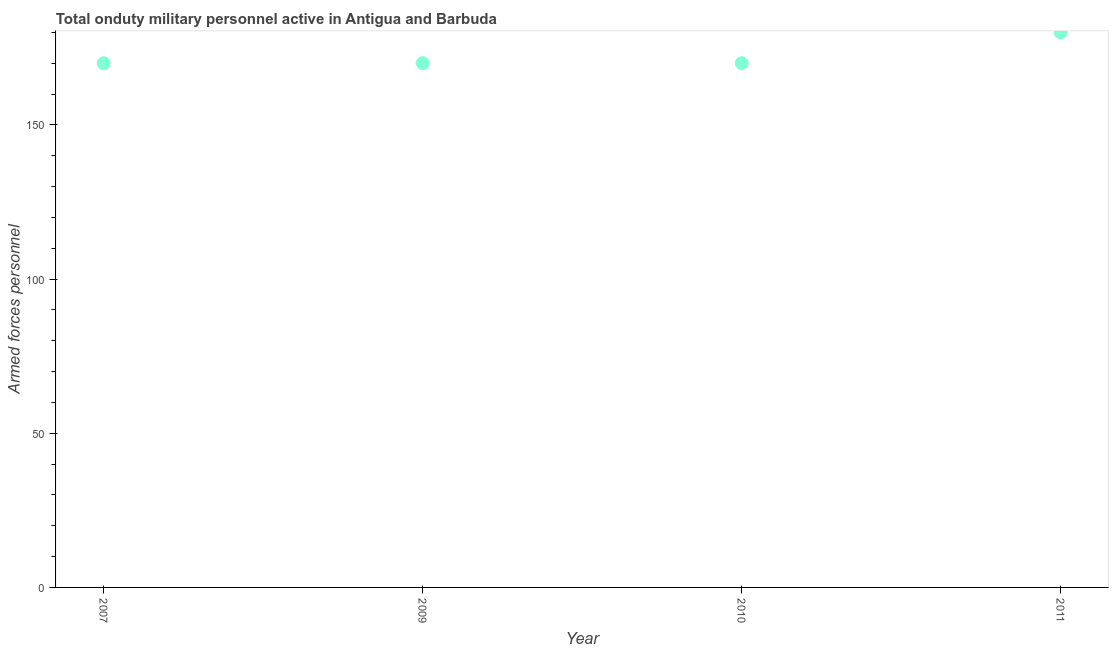What is the number of armed forces personnel in 2010?
Ensure brevity in your answer.  170. Across all years, what is the maximum number of armed forces personnel?
Your answer should be very brief. 180. Across all years, what is the minimum number of armed forces personnel?
Provide a succinct answer. 170. What is the sum of the number of armed forces personnel?
Your response must be concise. 690. What is the difference between the number of armed forces personnel in 2007 and 2011?
Offer a terse response. -10. What is the average number of armed forces personnel per year?
Your answer should be compact. 172.5. What is the median number of armed forces personnel?
Provide a short and direct response. 170. What is the ratio of the number of armed forces personnel in 2007 to that in 2010?
Your response must be concise. 1. What is the difference between the highest and the second highest number of armed forces personnel?
Ensure brevity in your answer.  10. Is the sum of the number of armed forces personnel in 2007 and 2011 greater than the maximum number of armed forces personnel across all years?
Your answer should be very brief. Yes. What is the difference between the highest and the lowest number of armed forces personnel?
Give a very brief answer. 10. Does the number of armed forces personnel monotonically increase over the years?
Provide a short and direct response. No. How many dotlines are there?
Your answer should be compact. 1. What is the difference between two consecutive major ticks on the Y-axis?
Provide a short and direct response. 50. Are the values on the major ticks of Y-axis written in scientific E-notation?
Offer a very short reply. No. Does the graph contain any zero values?
Ensure brevity in your answer.  No. Does the graph contain grids?
Your response must be concise. No. What is the title of the graph?
Keep it short and to the point. Total onduty military personnel active in Antigua and Barbuda. What is the label or title of the Y-axis?
Give a very brief answer. Armed forces personnel. What is the Armed forces personnel in 2007?
Your answer should be compact. 170. What is the Armed forces personnel in 2009?
Offer a terse response. 170. What is the Armed forces personnel in 2010?
Give a very brief answer. 170. What is the Armed forces personnel in 2011?
Offer a terse response. 180. What is the difference between the Armed forces personnel in 2007 and 2010?
Ensure brevity in your answer.  0. What is the difference between the Armed forces personnel in 2007 and 2011?
Offer a terse response. -10. What is the difference between the Armed forces personnel in 2009 and 2011?
Ensure brevity in your answer.  -10. What is the ratio of the Armed forces personnel in 2007 to that in 2010?
Your answer should be very brief. 1. What is the ratio of the Armed forces personnel in 2007 to that in 2011?
Ensure brevity in your answer.  0.94. What is the ratio of the Armed forces personnel in 2009 to that in 2010?
Keep it short and to the point. 1. What is the ratio of the Armed forces personnel in 2009 to that in 2011?
Provide a short and direct response. 0.94. What is the ratio of the Armed forces personnel in 2010 to that in 2011?
Keep it short and to the point. 0.94. 